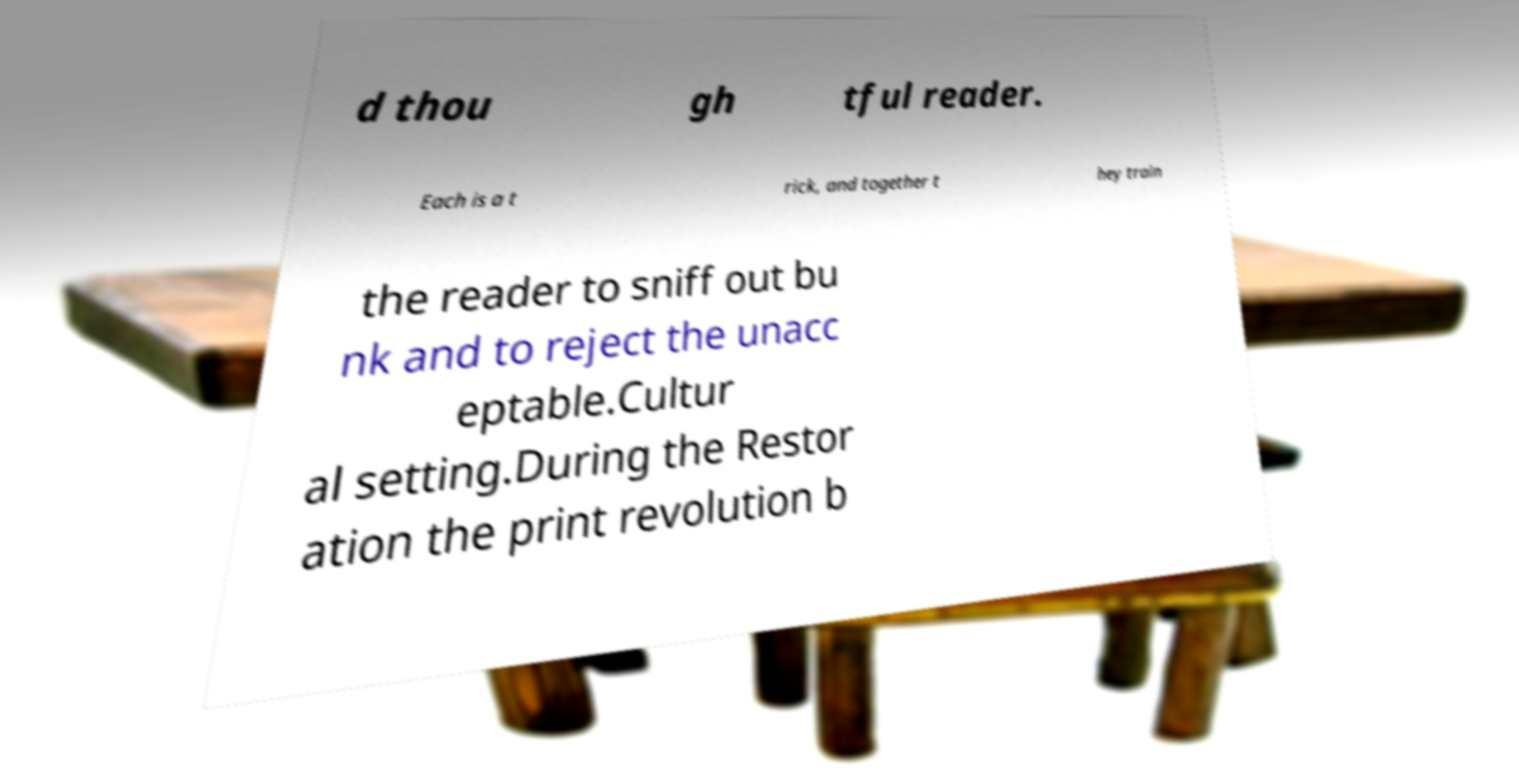I need the written content from this picture converted into text. Can you do that? d thou gh tful reader. Each is a t rick, and together t hey train the reader to sniff out bu nk and to reject the unacc eptable.Cultur al setting.During the Restor ation the print revolution b 